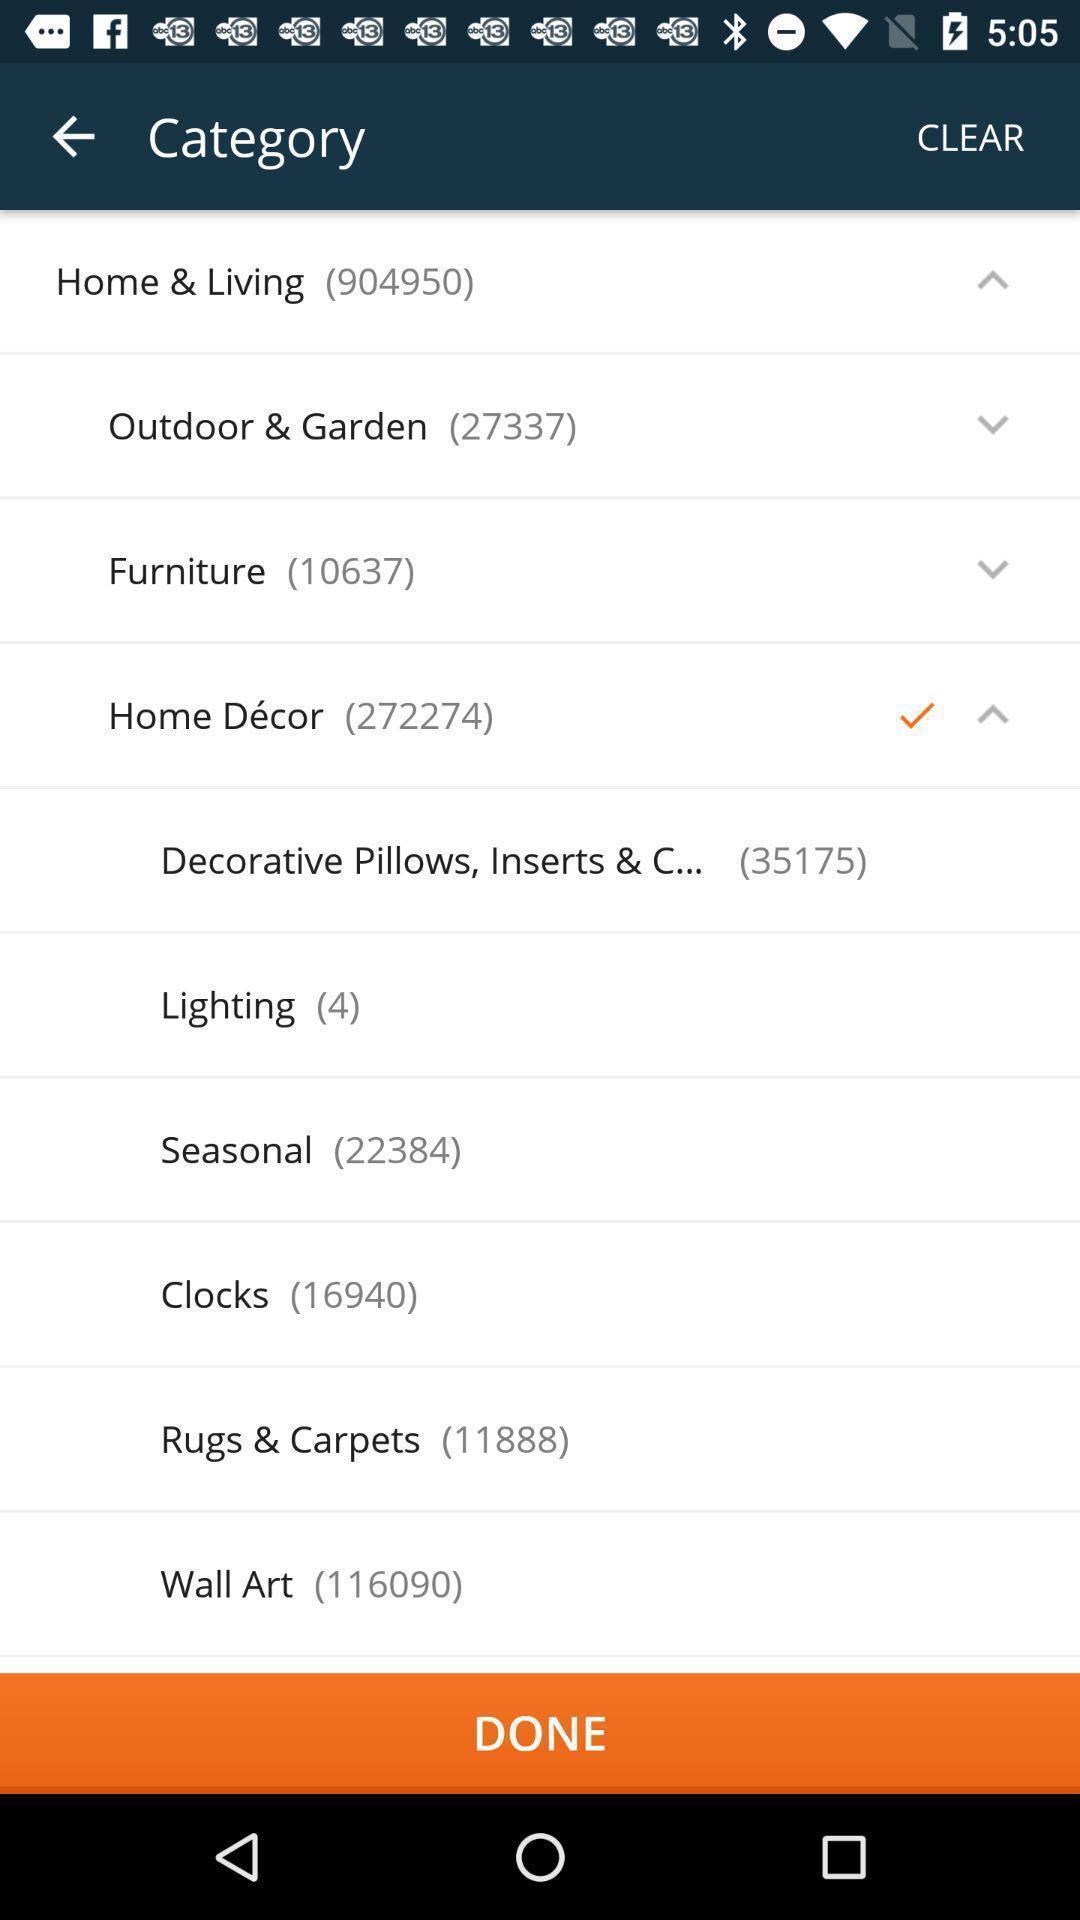Give me a summary of this screen capture. Screen displaying multiple categories with names in a shopping application. 